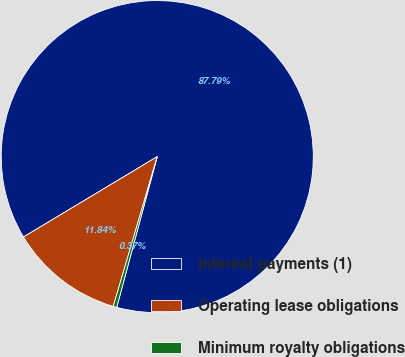<chart> <loc_0><loc_0><loc_500><loc_500><pie_chart><fcel>Interest payments (1)<fcel>Operating lease obligations<fcel>Minimum royalty obligations<nl><fcel>87.8%<fcel>11.84%<fcel>0.37%<nl></chart> 